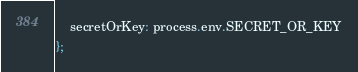<code> <loc_0><loc_0><loc_500><loc_500><_JavaScript_>    secretOrKey: process.env.SECRET_OR_KEY
};
</code> 